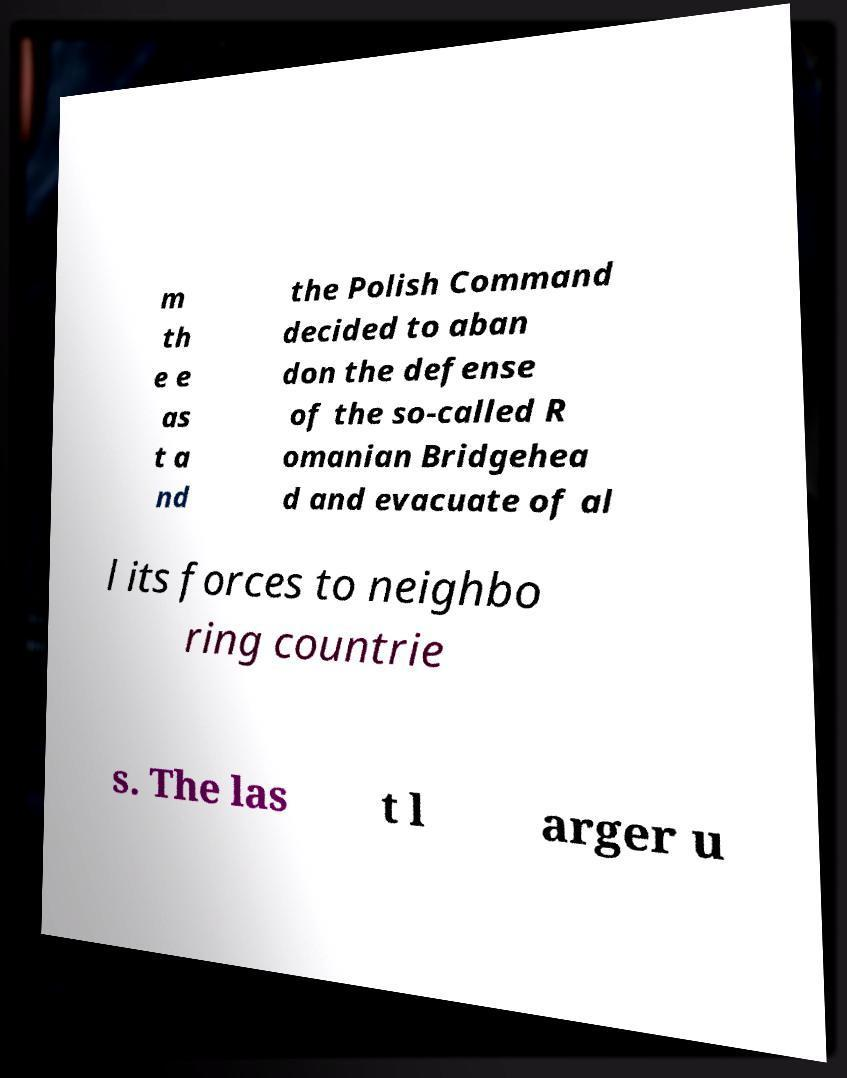Could you extract and type out the text from this image? m th e e as t a nd the Polish Command decided to aban don the defense of the so-called R omanian Bridgehea d and evacuate of al l its forces to neighbo ring countrie s. The las t l arger u 